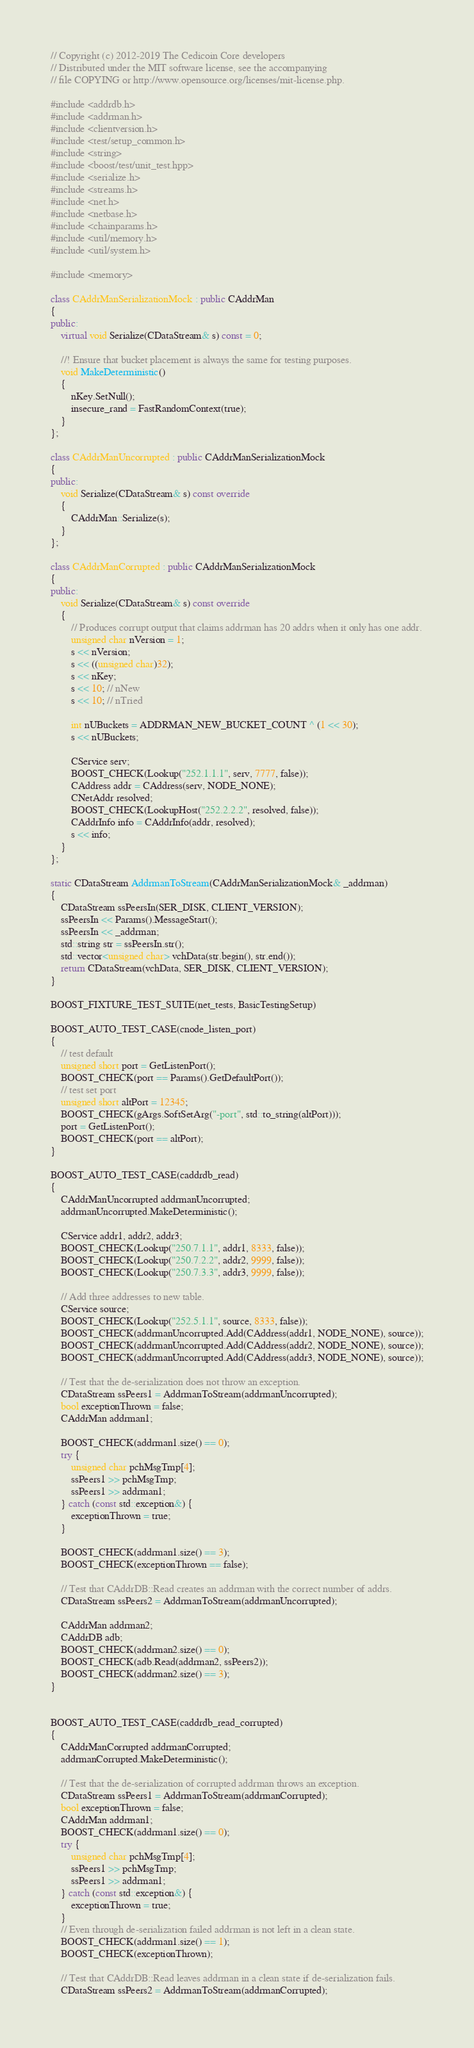<code> <loc_0><loc_0><loc_500><loc_500><_C++_>// Copyright (c) 2012-2019 The Cedicoin Core developers
// Distributed under the MIT software license, see the accompanying
// file COPYING or http://www.opensource.org/licenses/mit-license.php.

#include <addrdb.h>
#include <addrman.h>
#include <clientversion.h>
#include <test/setup_common.h>
#include <string>
#include <boost/test/unit_test.hpp>
#include <serialize.h>
#include <streams.h>
#include <net.h>
#include <netbase.h>
#include <chainparams.h>
#include <util/memory.h>
#include <util/system.h>

#include <memory>

class CAddrManSerializationMock : public CAddrMan
{
public:
    virtual void Serialize(CDataStream& s) const = 0;

    //! Ensure that bucket placement is always the same for testing purposes.
    void MakeDeterministic()
    {
        nKey.SetNull();
        insecure_rand = FastRandomContext(true);
    }
};

class CAddrManUncorrupted : public CAddrManSerializationMock
{
public:
    void Serialize(CDataStream& s) const override
    {
        CAddrMan::Serialize(s);
    }
};

class CAddrManCorrupted : public CAddrManSerializationMock
{
public:
    void Serialize(CDataStream& s) const override
    {
        // Produces corrupt output that claims addrman has 20 addrs when it only has one addr.
        unsigned char nVersion = 1;
        s << nVersion;
        s << ((unsigned char)32);
        s << nKey;
        s << 10; // nNew
        s << 10; // nTried

        int nUBuckets = ADDRMAN_NEW_BUCKET_COUNT ^ (1 << 30);
        s << nUBuckets;

        CService serv;
        BOOST_CHECK(Lookup("252.1.1.1", serv, 7777, false));
        CAddress addr = CAddress(serv, NODE_NONE);
        CNetAddr resolved;
        BOOST_CHECK(LookupHost("252.2.2.2", resolved, false));
        CAddrInfo info = CAddrInfo(addr, resolved);
        s << info;
    }
};

static CDataStream AddrmanToStream(CAddrManSerializationMock& _addrman)
{
    CDataStream ssPeersIn(SER_DISK, CLIENT_VERSION);
    ssPeersIn << Params().MessageStart();
    ssPeersIn << _addrman;
    std::string str = ssPeersIn.str();
    std::vector<unsigned char> vchData(str.begin(), str.end());
    return CDataStream(vchData, SER_DISK, CLIENT_VERSION);
}

BOOST_FIXTURE_TEST_SUITE(net_tests, BasicTestingSetup)

BOOST_AUTO_TEST_CASE(cnode_listen_port)
{
    // test default
    unsigned short port = GetListenPort();
    BOOST_CHECK(port == Params().GetDefaultPort());
    // test set port
    unsigned short altPort = 12345;
    BOOST_CHECK(gArgs.SoftSetArg("-port", std::to_string(altPort)));
    port = GetListenPort();
    BOOST_CHECK(port == altPort);
}

BOOST_AUTO_TEST_CASE(caddrdb_read)
{
    CAddrManUncorrupted addrmanUncorrupted;
    addrmanUncorrupted.MakeDeterministic();

    CService addr1, addr2, addr3;
    BOOST_CHECK(Lookup("250.7.1.1", addr1, 8333, false));
    BOOST_CHECK(Lookup("250.7.2.2", addr2, 9999, false));
    BOOST_CHECK(Lookup("250.7.3.3", addr3, 9999, false));

    // Add three addresses to new table.
    CService source;
    BOOST_CHECK(Lookup("252.5.1.1", source, 8333, false));
    BOOST_CHECK(addrmanUncorrupted.Add(CAddress(addr1, NODE_NONE), source));
    BOOST_CHECK(addrmanUncorrupted.Add(CAddress(addr2, NODE_NONE), source));
    BOOST_CHECK(addrmanUncorrupted.Add(CAddress(addr3, NODE_NONE), source));

    // Test that the de-serialization does not throw an exception.
    CDataStream ssPeers1 = AddrmanToStream(addrmanUncorrupted);
    bool exceptionThrown = false;
    CAddrMan addrman1;

    BOOST_CHECK(addrman1.size() == 0);
    try {
        unsigned char pchMsgTmp[4];
        ssPeers1 >> pchMsgTmp;
        ssPeers1 >> addrman1;
    } catch (const std::exception&) {
        exceptionThrown = true;
    }

    BOOST_CHECK(addrman1.size() == 3);
    BOOST_CHECK(exceptionThrown == false);

    // Test that CAddrDB::Read creates an addrman with the correct number of addrs.
    CDataStream ssPeers2 = AddrmanToStream(addrmanUncorrupted);

    CAddrMan addrman2;
    CAddrDB adb;
    BOOST_CHECK(addrman2.size() == 0);
    BOOST_CHECK(adb.Read(addrman2, ssPeers2));
    BOOST_CHECK(addrman2.size() == 3);
}


BOOST_AUTO_TEST_CASE(caddrdb_read_corrupted)
{
    CAddrManCorrupted addrmanCorrupted;
    addrmanCorrupted.MakeDeterministic();

    // Test that the de-serialization of corrupted addrman throws an exception.
    CDataStream ssPeers1 = AddrmanToStream(addrmanCorrupted);
    bool exceptionThrown = false;
    CAddrMan addrman1;
    BOOST_CHECK(addrman1.size() == 0);
    try {
        unsigned char pchMsgTmp[4];
        ssPeers1 >> pchMsgTmp;
        ssPeers1 >> addrman1;
    } catch (const std::exception&) {
        exceptionThrown = true;
    }
    // Even through de-serialization failed addrman is not left in a clean state.
    BOOST_CHECK(addrman1.size() == 1);
    BOOST_CHECK(exceptionThrown);

    // Test that CAddrDB::Read leaves addrman in a clean state if de-serialization fails.
    CDataStream ssPeers2 = AddrmanToStream(addrmanCorrupted);
</code> 